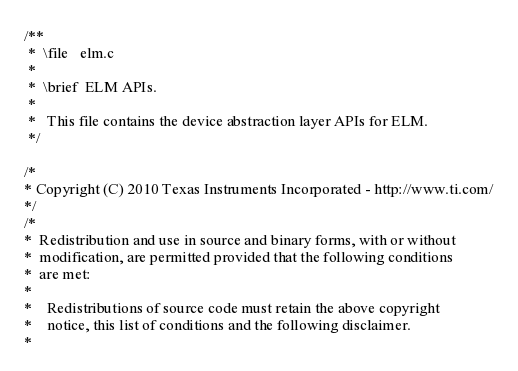<code> <loc_0><loc_0><loc_500><loc_500><_C_>/**
 *  \file   elm.c
 *
 *  \brief  ELM APIs.
 *
 *   This file contains the device abstraction layer APIs for ELM.
 */

/*
* Copyright (C) 2010 Texas Instruments Incorporated - http://www.ti.com/
*/
/*
*  Redistribution and use in source and binary forms, with or without
*  modification, are permitted provided that the following conditions
*  are met:
*
*    Redistributions of source code must retain the above copyright
*    notice, this list of conditions and the following disclaimer.
*</code> 